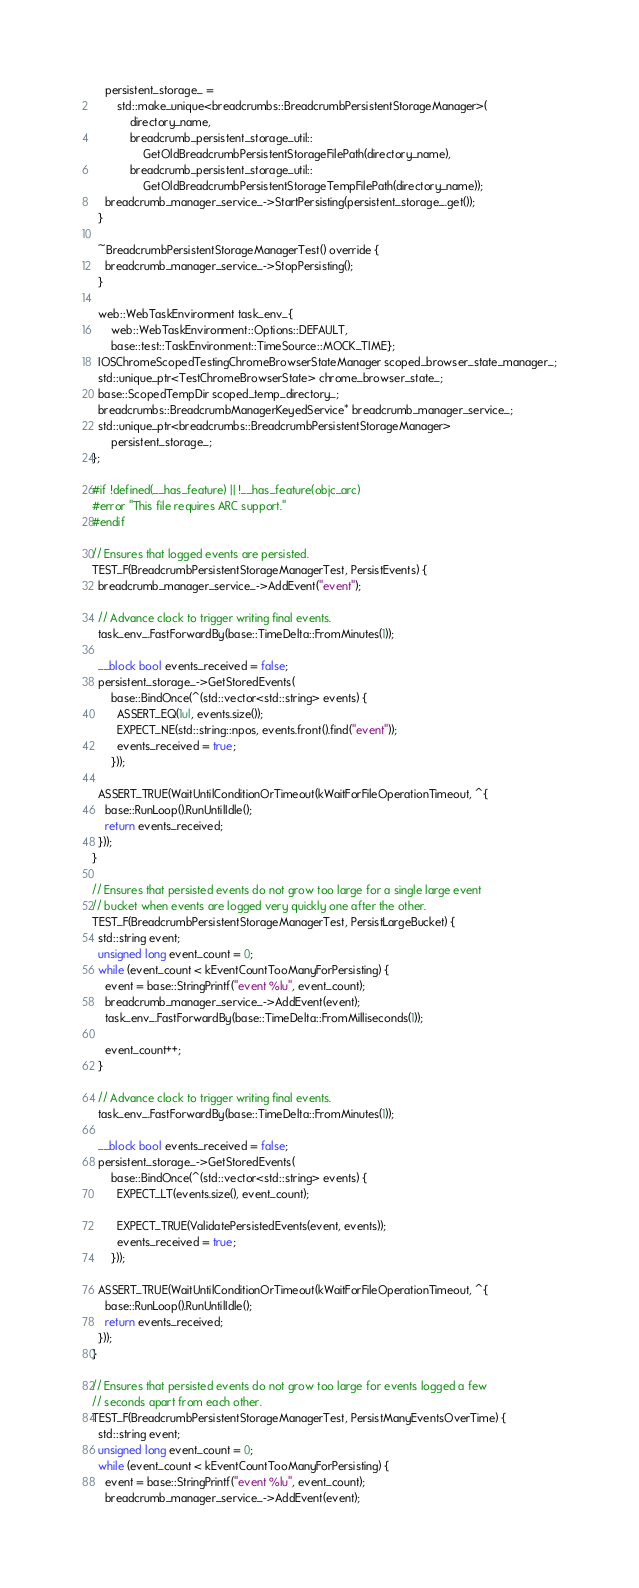Convert code to text. <code><loc_0><loc_0><loc_500><loc_500><_ObjectiveC_>    persistent_storage_ =
        std::make_unique<breadcrumbs::BreadcrumbPersistentStorageManager>(
            directory_name,
            breadcrumb_persistent_storage_util::
                GetOldBreadcrumbPersistentStorageFilePath(directory_name),
            breadcrumb_persistent_storage_util::
                GetOldBreadcrumbPersistentStorageTempFilePath(directory_name));
    breadcrumb_manager_service_->StartPersisting(persistent_storage_.get());
  }

  ~BreadcrumbPersistentStorageManagerTest() override {
    breadcrumb_manager_service_->StopPersisting();
  }

  web::WebTaskEnvironment task_env_{
      web::WebTaskEnvironment::Options::DEFAULT,
      base::test::TaskEnvironment::TimeSource::MOCK_TIME};
  IOSChromeScopedTestingChromeBrowserStateManager scoped_browser_state_manager_;
  std::unique_ptr<TestChromeBrowserState> chrome_browser_state_;
  base::ScopedTempDir scoped_temp_directory_;
  breadcrumbs::BreadcrumbManagerKeyedService* breadcrumb_manager_service_;
  std::unique_ptr<breadcrumbs::BreadcrumbPersistentStorageManager>
      persistent_storage_;
};

#if !defined(__has_feature) || !__has_feature(objc_arc)
#error "This file requires ARC support."
#endif

// Ensures that logged events are persisted.
TEST_F(BreadcrumbPersistentStorageManagerTest, PersistEvents) {
  breadcrumb_manager_service_->AddEvent("event");

  // Advance clock to trigger writing final events.
  task_env_.FastForwardBy(base::TimeDelta::FromMinutes(1));

  __block bool events_received = false;
  persistent_storage_->GetStoredEvents(
      base::BindOnce(^(std::vector<std::string> events) {
        ASSERT_EQ(1ul, events.size());
        EXPECT_NE(std::string::npos, events.front().find("event"));
        events_received = true;
      }));

  ASSERT_TRUE(WaitUntilConditionOrTimeout(kWaitForFileOperationTimeout, ^{
    base::RunLoop().RunUntilIdle();
    return events_received;
  }));
}

// Ensures that persisted events do not grow too large for a single large event
// bucket when events are logged very quickly one after the other.
TEST_F(BreadcrumbPersistentStorageManagerTest, PersistLargeBucket) {
  std::string event;
  unsigned long event_count = 0;
  while (event_count < kEventCountTooManyForPersisting) {
    event = base::StringPrintf("event %lu", event_count);
    breadcrumb_manager_service_->AddEvent(event);
    task_env_.FastForwardBy(base::TimeDelta::FromMilliseconds(1));

    event_count++;
  }

  // Advance clock to trigger writing final events.
  task_env_.FastForwardBy(base::TimeDelta::FromMinutes(1));

  __block bool events_received = false;
  persistent_storage_->GetStoredEvents(
      base::BindOnce(^(std::vector<std::string> events) {
        EXPECT_LT(events.size(), event_count);

        EXPECT_TRUE(ValidatePersistedEvents(event, events));
        events_received = true;
      }));

  ASSERT_TRUE(WaitUntilConditionOrTimeout(kWaitForFileOperationTimeout, ^{
    base::RunLoop().RunUntilIdle();
    return events_received;
  }));
}

// Ensures that persisted events do not grow too large for events logged a few
// seconds apart from each other.
TEST_F(BreadcrumbPersistentStorageManagerTest, PersistManyEventsOverTime) {
  std::string event;
  unsigned long event_count = 0;
  while (event_count < kEventCountTooManyForPersisting) {
    event = base::StringPrintf("event %lu", event_count);
    breadcrumb_manager_service_->AddEvent(event);</code> 